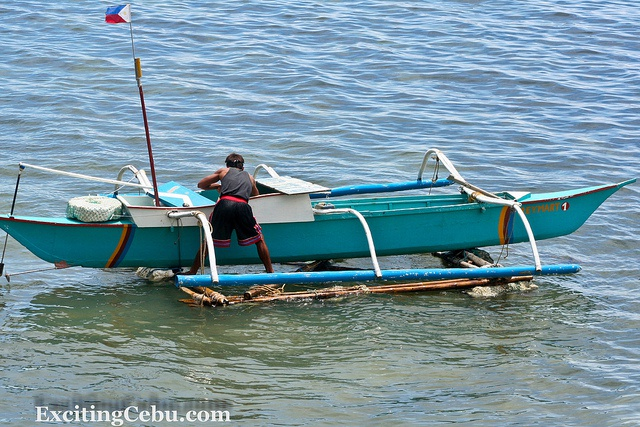Describe the objects in this image and their specific colors. I can see boat in lightblue, teal, darkgray, and white tones and people in lightblue, black, gray, maroon, and brown tones in this image. 